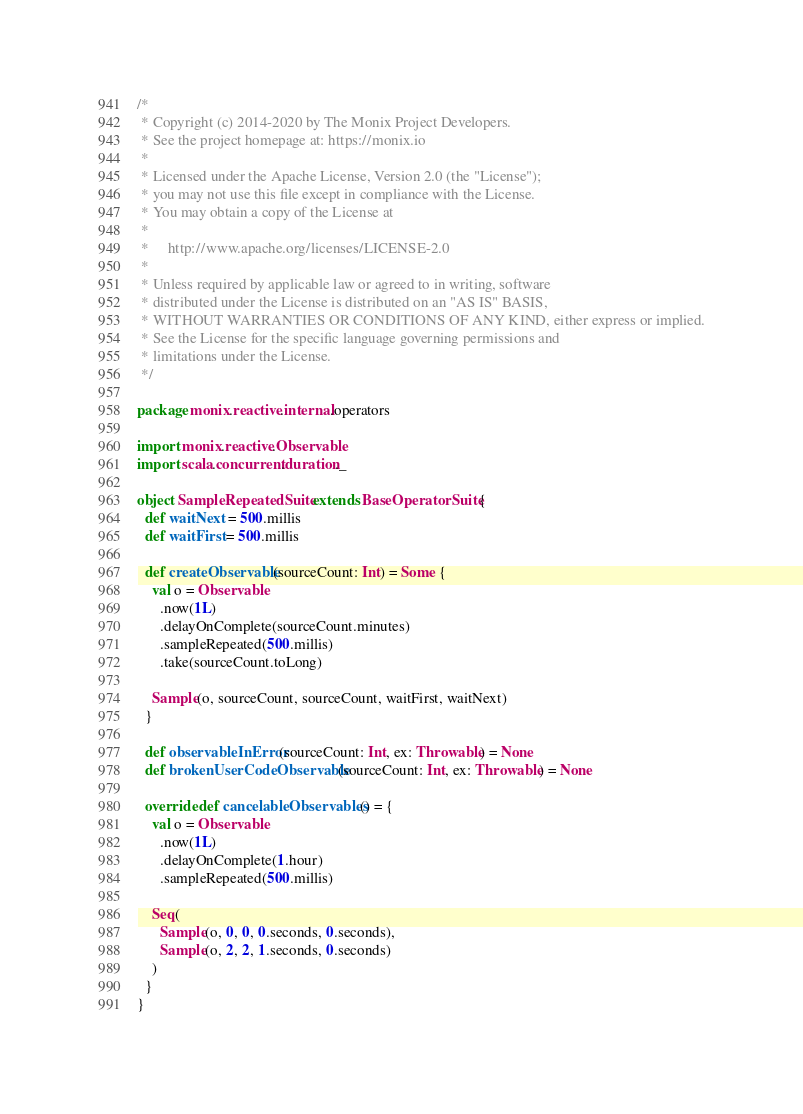<code> <loc_0><loc_0><loc_500><loc_500><_Scala_>/*
 * Copyright (c) 2014-2020 by The Monix Project Developers.
 * See the project homepage at: https://monix.io
 *
 * Licensed under the Apache License, Version 2.0 (the "License");
 * you may not use this file except in compliance with the License.
 * You may obtain a copy of the License at
 *
 *     http://www.apache.org/licenses/LICENSE-2.0
 *
 * Unless required by applicable law or agreed to in writing, software
 * distributed under the License is distributed on an "AS IS" BASIS,
 * WITHOUT WARRANTIES OR CONDITIONS OF ANY KIND, either express or implied.
 * See the License for the specific language governing permissions and
 * limitations under the License.
 */

package monix.reactive.internal.operators

import monix.reactive.Observable
import scala.concurrent.duration._

object SampleRepeatedSuite extends BaseOperatorSuite {
  def waitNext = 500.millis
  def waitFirst = 500.millis

  def createObservable(sourceCount: Int) = Some {
    val o = Observable
      .now(1L)
      .delayOnComplete(sourceCount.minutes)
      .sampleRepeated(500.millis)
      .take(sourceCount.toLong)

    Sample(o, sourceCount, sourceCount, waitFirst, waitNext)
  }

  def observableInError(sourceCount: Int, ex: Throwable) = None
  def brokenUserCodeObservable(sourceCount: Int, ex: Throwable) = None

  override def cancelableObservables() = {
    val o = Observable
      .now(1L)
      .delayOnComplete(1.hour)
      .sampleRepeated(500.millis)

    Seq(
      Sample(o, 0, 0, 0.seconds, 0.seconds),
      Sample(o, 2, 2, 1.seconds, 0.seconds)
    )
  }
}
</code> 